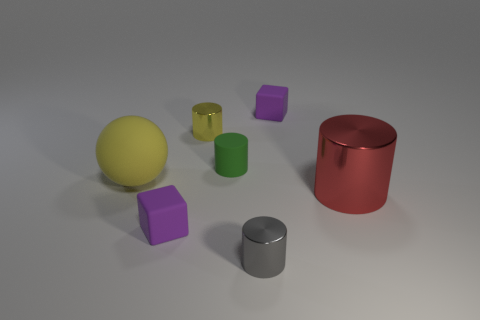Subtract all red blocks. Subtract all yellow cylinders. How many blocks are left? 2 Add 2 red objects. How many objects exist? 9 Subtract all cylinders. How many objects are left? 3 Subtract 0 red blocks. How many objects are left? 7 Subtract all purple matte objects. Subtract all rubber cubes. How many objects are left? 3 Add 5 large things. How many large things are left? 7 Add 5 small purple matte objects. How many small purple matte objects exist? 7 